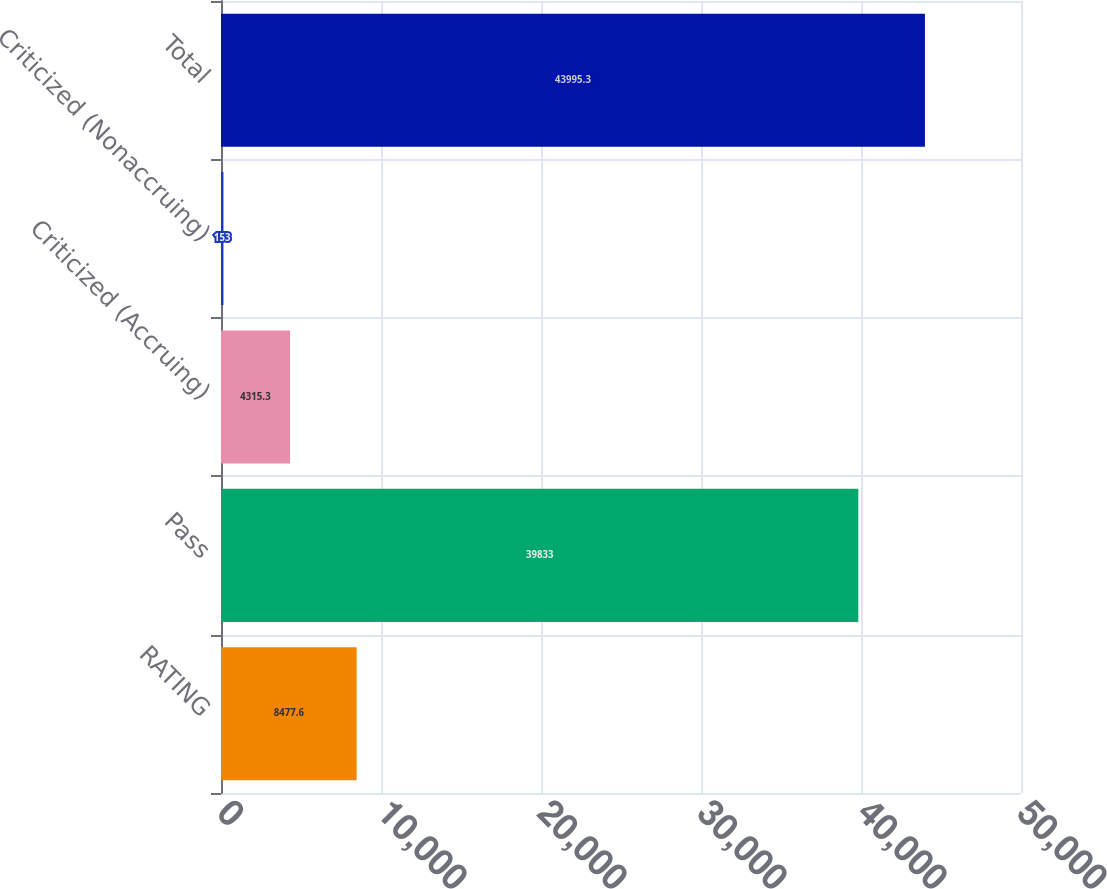Convert chart to OTSL. <chart><loc_0><loc_0><loc_500><loc_500><bar_chart><fcel>RATING<fcel>Pass<fcel>Criticized (Accruing)<fcel>Criticized (Nonaccruing)<fcel>Total<nl><fcel>8477.6<fcel>39833<fcel>4315.3<fcel>153<fcel>43995.3<nl></chart> 